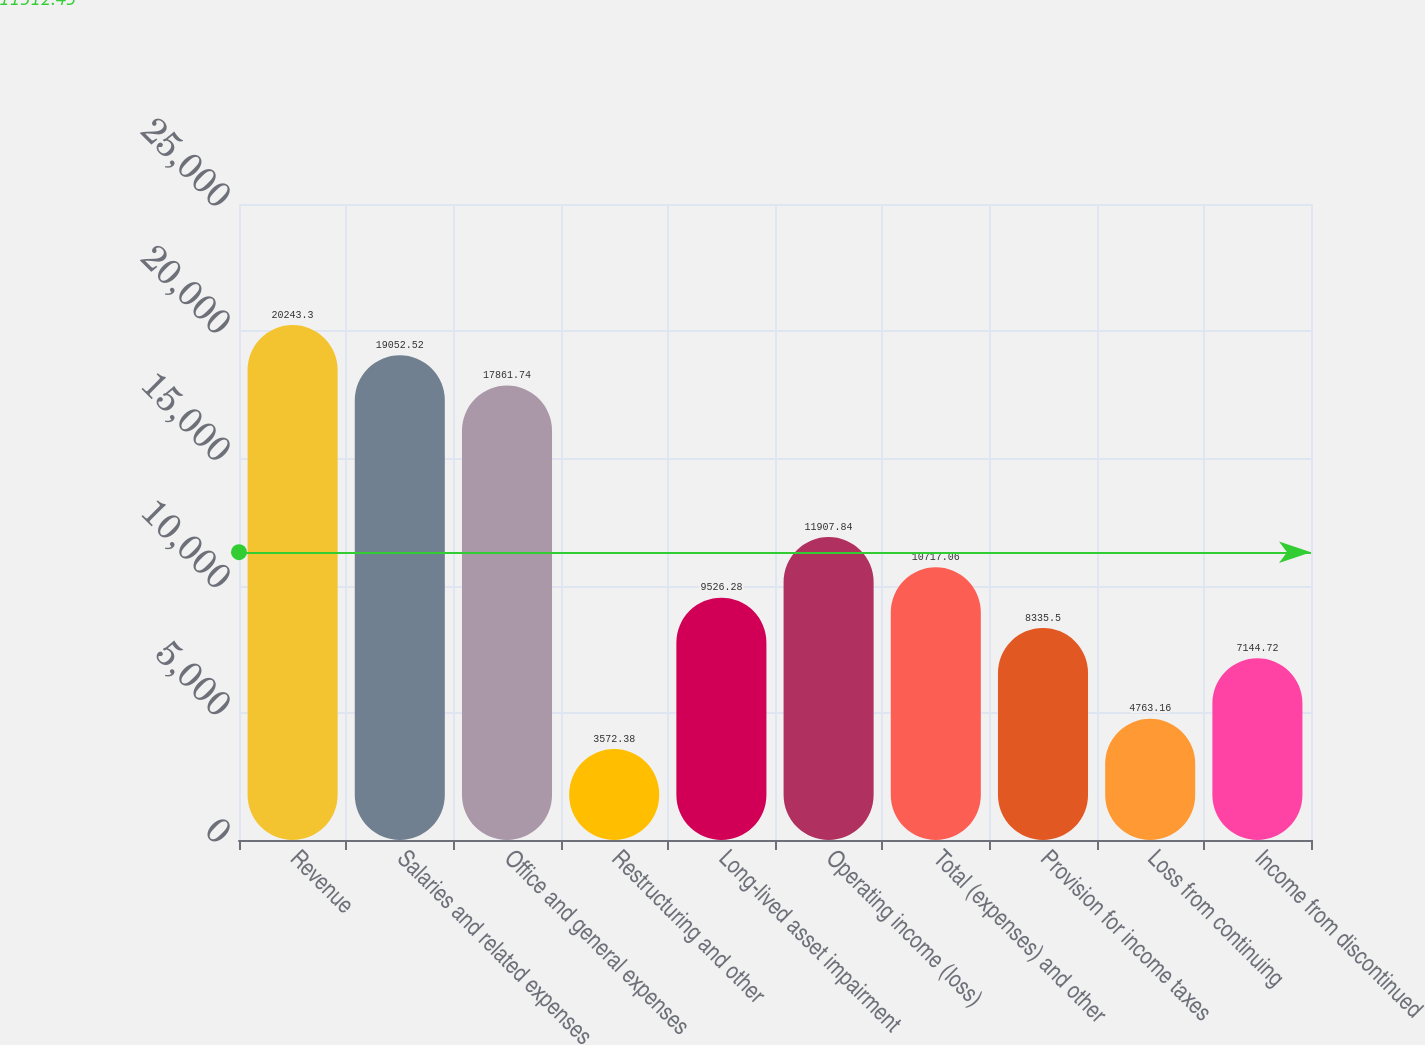Convert chart. <chart><loc_0><loc_0><loc_500><loc_500><bar_chart><fcel>Revenue<fcel>Salaries and related expenses<fcel>Office and general expenses<fcel>Restructuring and other<fcel>Long-lived asset impairment<fcel>Operating income (loss)<fcel>Total (expenses) and other<fcel>Provision for income taxes<fcel>Loss from continuing<fcel>Income from discontinued<nl><fcel>20243.3<fcel>19052.5<fcel>17861.7<fcel>3572.38<fcel>9526.28<fcel>11907.8<fcel>10717.1<fcel>8335.5<fcel>4763.16<fcel>7144.72<nl></chart> 